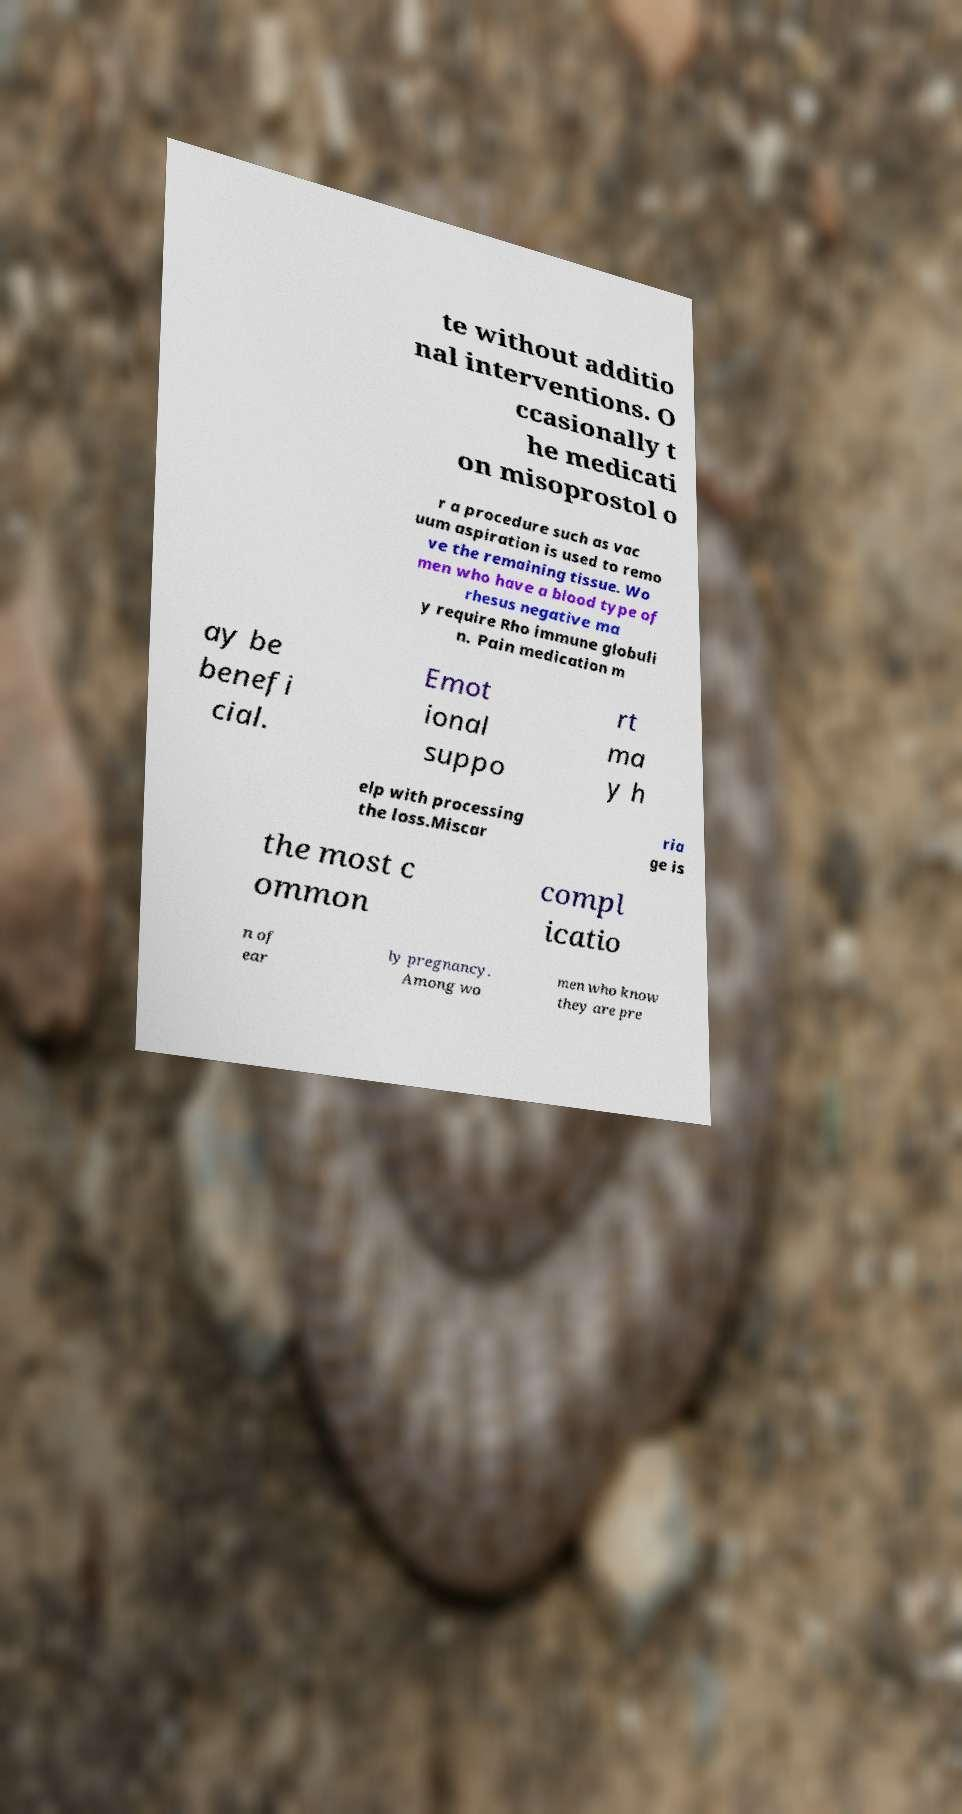Could you assist in decoding the text presented in this image and type it out clearly? te without additio nal interventions. O ccasionally t he medicati on misoprostol o r a procedure such as vac uum aspiration is used to remo ve the remaining tissue. Wo men who have a blood type of rhesus negative ma y require Rho immune globuli n. Pain medication m ay be benefi cial. Emot ional suppo rt ma y h elp with processing the loss.Miscar ria ge is the most c ommon compl icatio n of ear ly pregnancy. Among wo men who know they are pre 